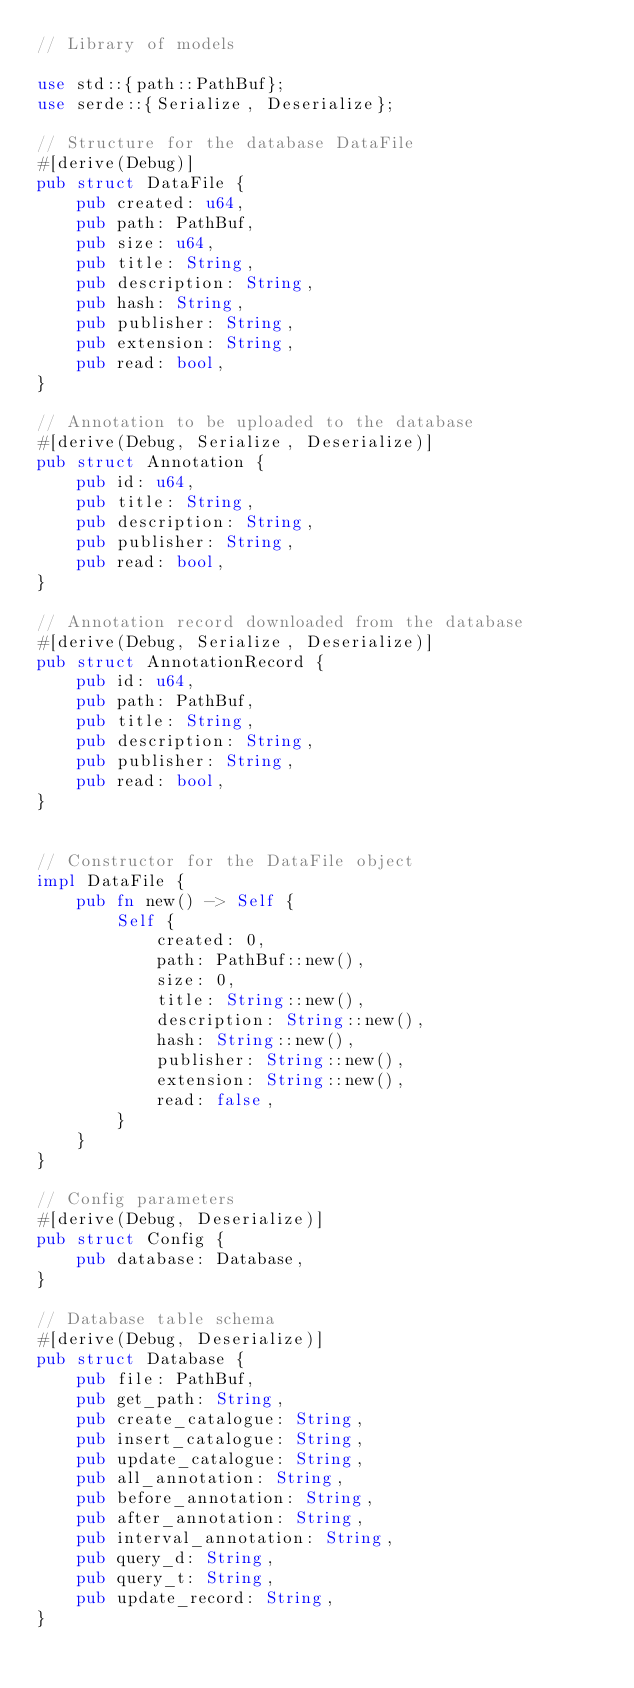Convert code to text. <code><loc_0><loc_0><loc_500><loc_500><_Rust_>// Library of models

use std::{path::PathBuf};
use serde::{Serialize, Deserialize};

// Structure for the database DataFile
#[derive(Debug)]
pub struct DataFile {
    pub created: u64,
    pub path: PathBuf,
    pub size: u64,
    pub title: String,
    pub description: String,
    pub hash: String,
    pub publisher: String,
    pub extension: String,
    pub read: bool,
}

// Annotation to be uploaded to the database
#[derive(Debug, Serialize, Deserialize)]
pub struct Annotation {
    pub id: u64,
    pub title: String,
    pub description: String,
    pub publisher: String,
    pub read: bool,
}

// Annotation record downloaded from the database
#[derive(Debug, Serialize, Deserialize)]
pub struct AnnotationRecord {
    pub id: u64,
    pub path: PathBuf,
    pub title: String,
    pub description: String,
    pub publisher: String,
    pub read: bool,
}


// Constructor for the DataFile object
impl DataFile {
    pub fn new() -> Self {
        Self {
            created: 0,
            path: PathBuf::new(),
            size: 0,
            title: String::new(),
            description: String::new(),
            hash: String::new(),
            publisher: String::new(),
            extension: String::new(),
            read: false,
        }
    }
}

// Config parameters
#[derive(Debug, Deserialize)]
pub struct Config {
    pub database: Database,
}

// Database table schema
#[derive(Debug, Deserialize)]
pub struct Database {
    pub file: PathBuf,
    pub get_path: String,
    pub create_catalogue: String,
    pub insert_catalogue: String,
    pub update_catalogue: String,
    pub all_annotation: String,
    pub before_annotation: String,
    pub after_annotation: String,
    pub interval_annotation: String,
    pub query_d: String,
    pub query_t: String,
    pub update_record: String,
}
</code> 